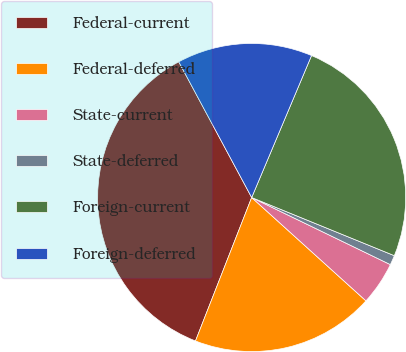<chart> <loc_0><loc_0><loc_500><loc_500><pie_chart><fcel>Federal-current<fcel>Federal-deferred<fcel>State-current<fcel>State-deferred<fcel>Foreign-current<fcel>Foreign-deferred<nl><fcel>36.21%<fcel>19.24%<fcel>4.53%<fcel>1.01%<fcel>24.81%<fcel>14.2%<nl></chart> 